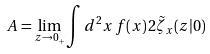Convert formula to latex. <formula><loc_0><loc_0><loc_500><loc_500>A = \lim _ { z \rightarrow 0 _ { + } } \int d ^ { 2 } x \, f ( x ) \, 2 \tilde { \zeta } _ { x } ( z | 0 )</formula> 